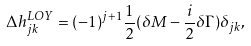Convert formula to latex. <formula><loc_0><loc_0><loc_500><loc_500>\Delta h _ { j k } ^ { L O Y } = ( - 1 ) ^ { j + 1 } \frac { 1 } { 2 } ( \delta M - \frac { i } { 2 } \delta \Gamma ) { \delta } _ { j k } ,</formula> 